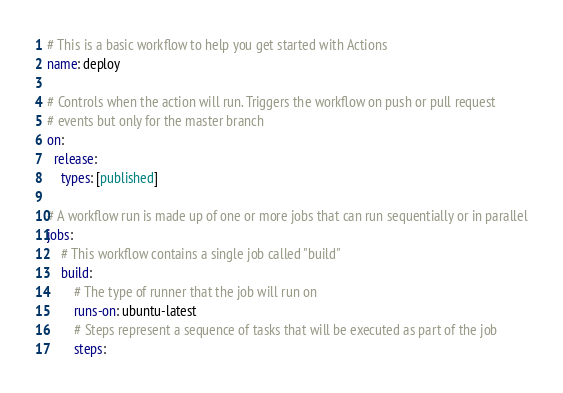<code> <loc_0><loc_0><loc_500><loc_500><_YAML_># This is a basic workflow to help you get started with Actions
name: deploy

# Controls when the action will run. Triggers the workflow on push or pull request
# events but only for the master branch
on:
  release:
    types: [published]

# A workflow run is made up of one or more jobs that can run sequentially or in parallel
jobs:
    # This workflow contains a single job called "build"
    build:
        # The type of runner that the job will run on
        runs-on: ubuntu-latest
        # Steps represent a sequence of tasks that will be executed as part of the job
        steps:</code> 